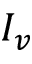<formula> <loc_0><loc_0><loc_500><loc_500>I _ { v }</formula> 